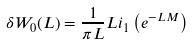<formula> <loc_0><loc_0><loc_500><loc_500>\delta W _ { 0 } ( L ) = \frac { 1 } { \pi L } L i _ { 1 } \left ( e ^ { - L M } \right )</formula> 